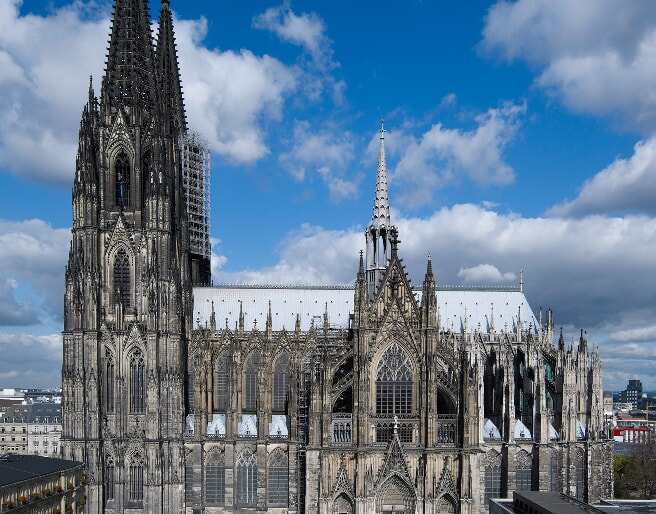Describe a hypothetical scenario where the Cologne Cathedral is the centerpiece of an intergalactic civilization. In a distant future where humanity has extended its reach beyond the stars, the Cologne Cathedral stands preserved as the nucleus of an intergalactic civilization. Picture a colossal space station orbiting a terraformed planet, with the cathedral serving as the central hub, its ancient stones juxtaposed against the backdrop of the cosmos. The spires have been reinforced with advanced materials, gleaming under the light of distant stars, while zero-gravity pathways allow pilgrims from various planets to visit with ease. The stained glass now features holographic displays recounting the history of humanity’s journey from Earth to the stars. Surrounding the cathedral are floating biodomes, each representing a different colony, filled with diverse flora and fauna from across the galaxy. The flying buttresses act as docking stations for sleek spacecraft, their designs inspired by the gothic arches of old. Within the cathedral, the sacred and the scientific coexist; quantum processors hum beneath altars, and cosmic sermons are transmitted through neural networks directly into visitors’ minds. This scenario melds the reverence of ancient history with the awe of futuristic innovation, showcasing the timeless nature of human spirit, faith, and perseverance. Can you provide a shorter description of this intergalactic Cologne Cathedral scenario? In an intergalactic future, the Cologne Cathedral floats at the heart of a massive space station, preserved as a symbol of human heritage amidst the stars. Reinforced spires gleam under distant suns, and zero-gravity pathways enable pilgrims from across the galaxy to visit. The stained-glass windows display holographic histories, while flying buttresses serve as docking bays for advanced spacecraft. Inside, quantum technology coexists with centuries-old altars, blending the sacred and scientific in an awe-inspiring tribute to humanity’s journey from Earth to the cosmos. 